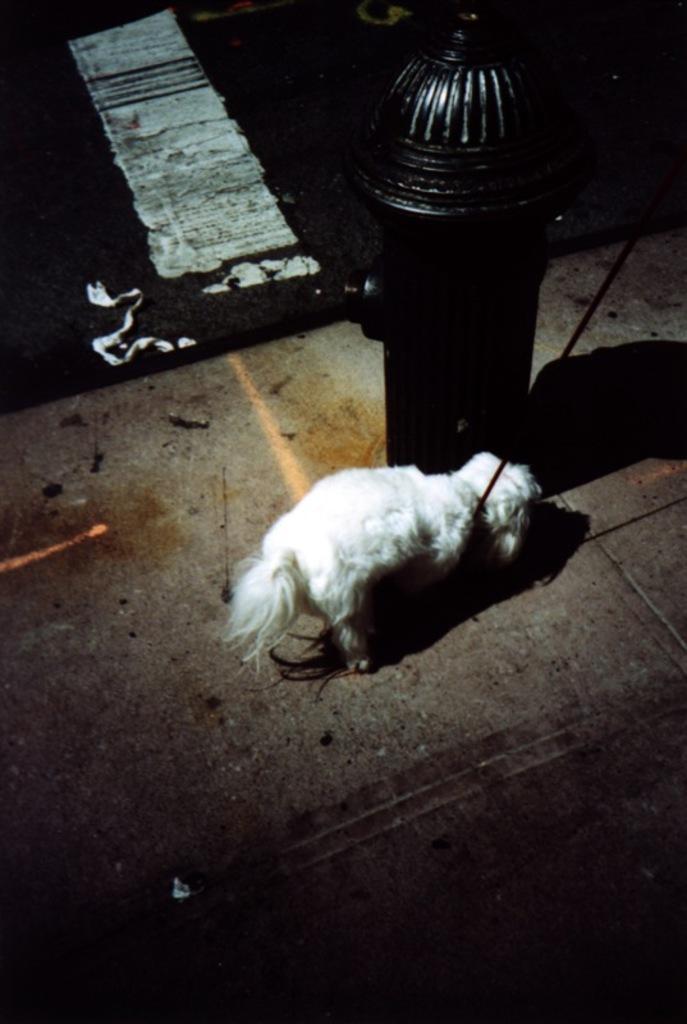Could you give a brief overview of what you see in this image? In this image I can see the dog which is in white color. To the side of the dog I can see the fire hydrant. And there is a white and black background. 